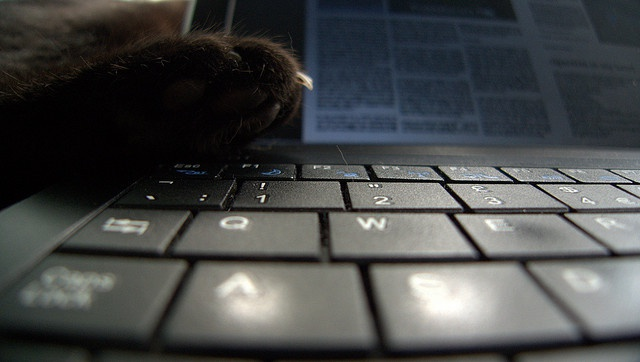Describe the objects in this image and their specific colors. I can see laptop in black, teal, gray, and darkgray tones, keyboard in teal, gray, black, darkgray, and lightgray tones, and cat in teal, black, and gray tones in this image. 